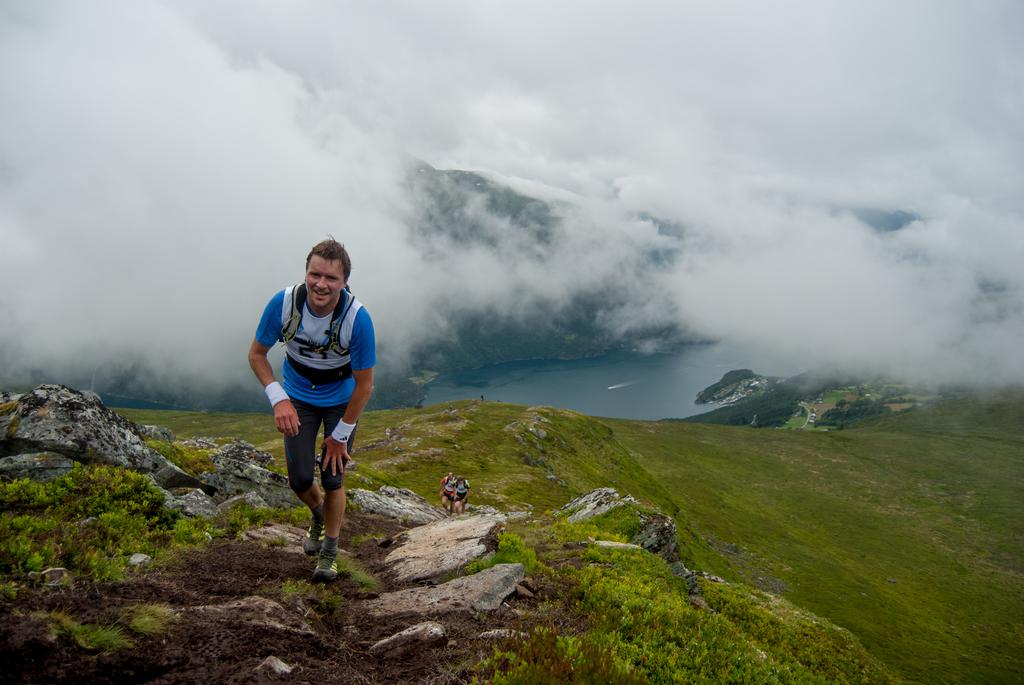What is the main subject of the picture? The main subject of the picture is people. Where are the people located in the image? The people are in the middle of the picture. What can be seen in the background of the image? There is a river and clouds in the sky in the background of the image. What type of fiction is the user reading in the image? There is no user or book present in the image, so it cannot be determined if anyone is reading fiction. 